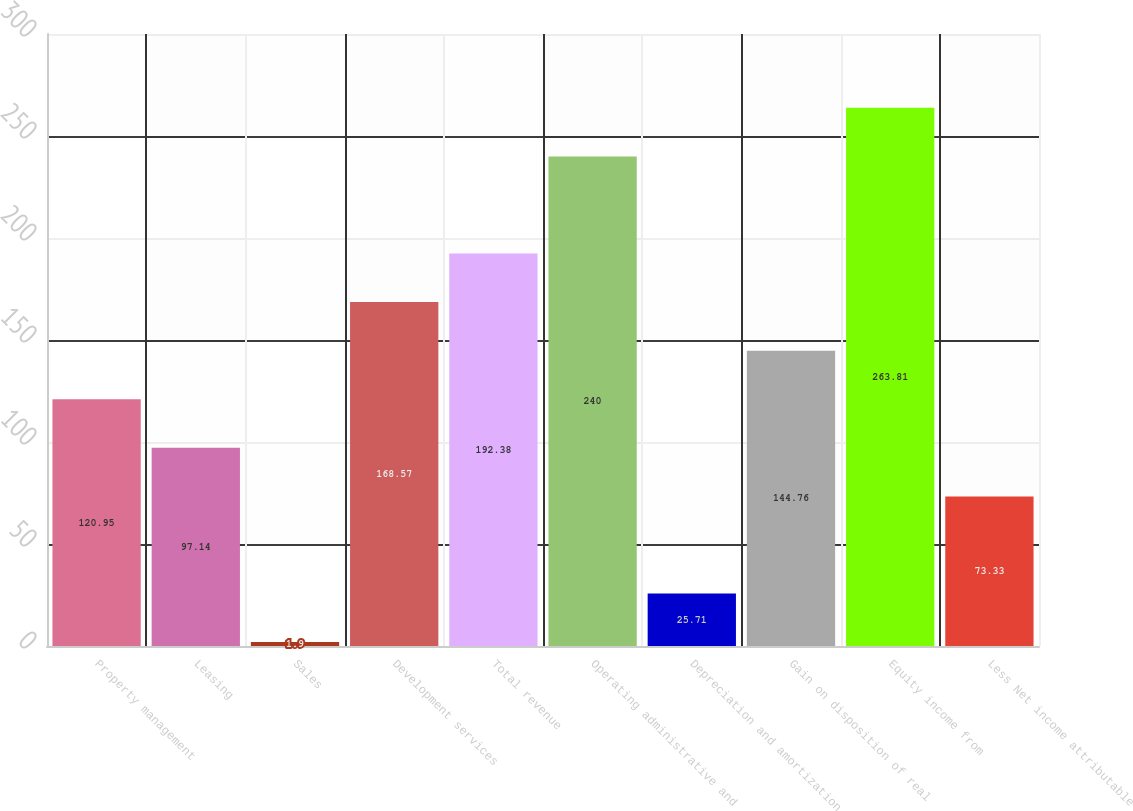Convert chart to OTSL. <chart><loc_0><loc_0><loc_500><loc_500><bar_chart><fcel>Property management<fcel>Leasing<fcel>Sales<fcel>Development services<fcel>Total revenue<fcel>Operating administrative and<fcel>Depreciation and amortization<fcel>Gain on disposition of real<fcel>Equity income from<fcel>Less Net income attributable<nl><fcel>120.95<fcel>97.14<fcel>1.9<fcel>168.57<fcel>192.38<fcel>240<fcel>25.71<fcel>144.76<fcel>263.81<fcel>73.33<nl></chart> 